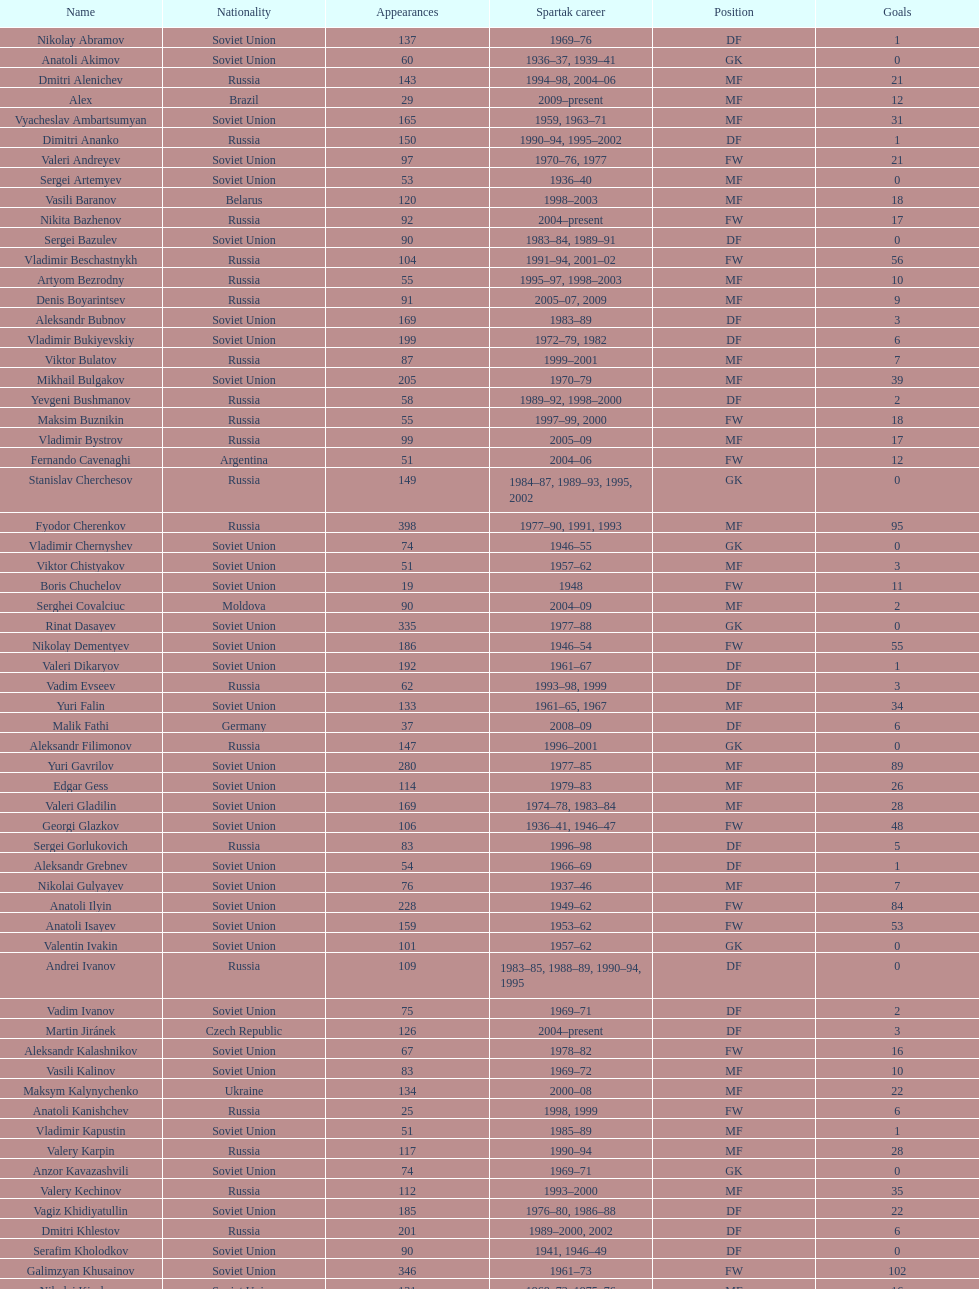Baranov has played from 2004 to the present. what is his nationality? Belarus. 